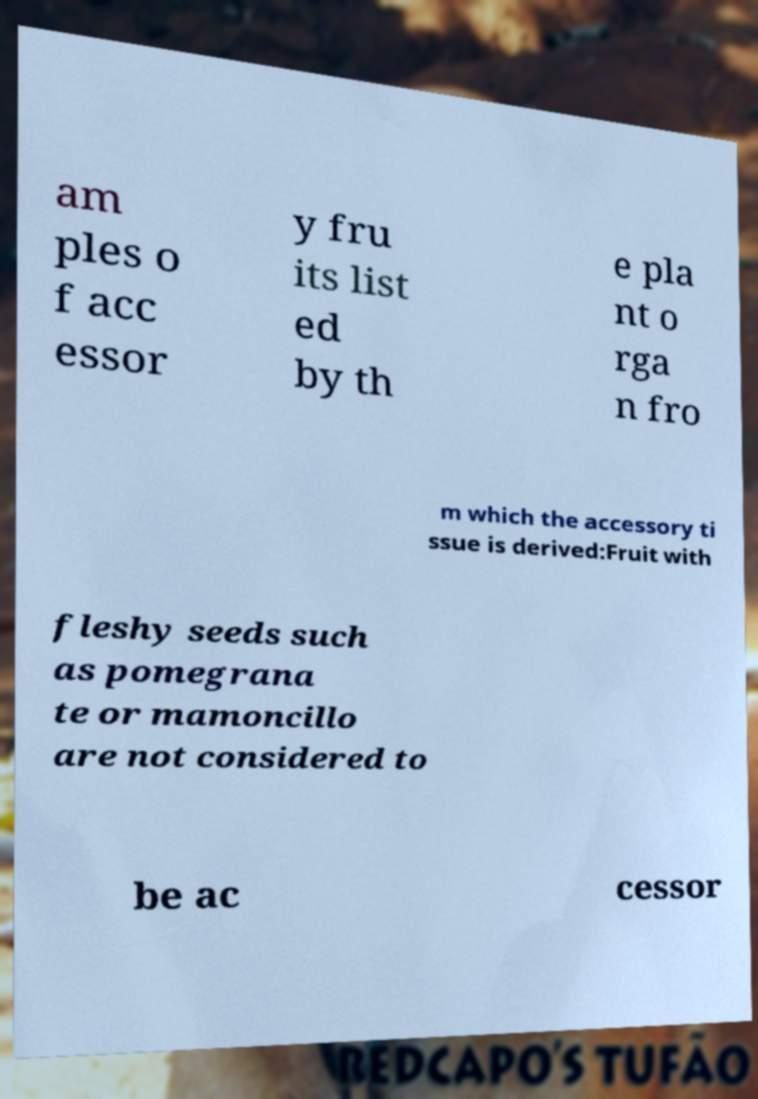Could you assist in decoding the text presented in this image and type it out clearly? am ples o f acc essor y fru its list ed by th e pla nt o rga n fro m which the accessory ti ssue is derived:Fruit with fleshy seeds such as pomegrana te or mamoncillo are not considered to be ac cessor 